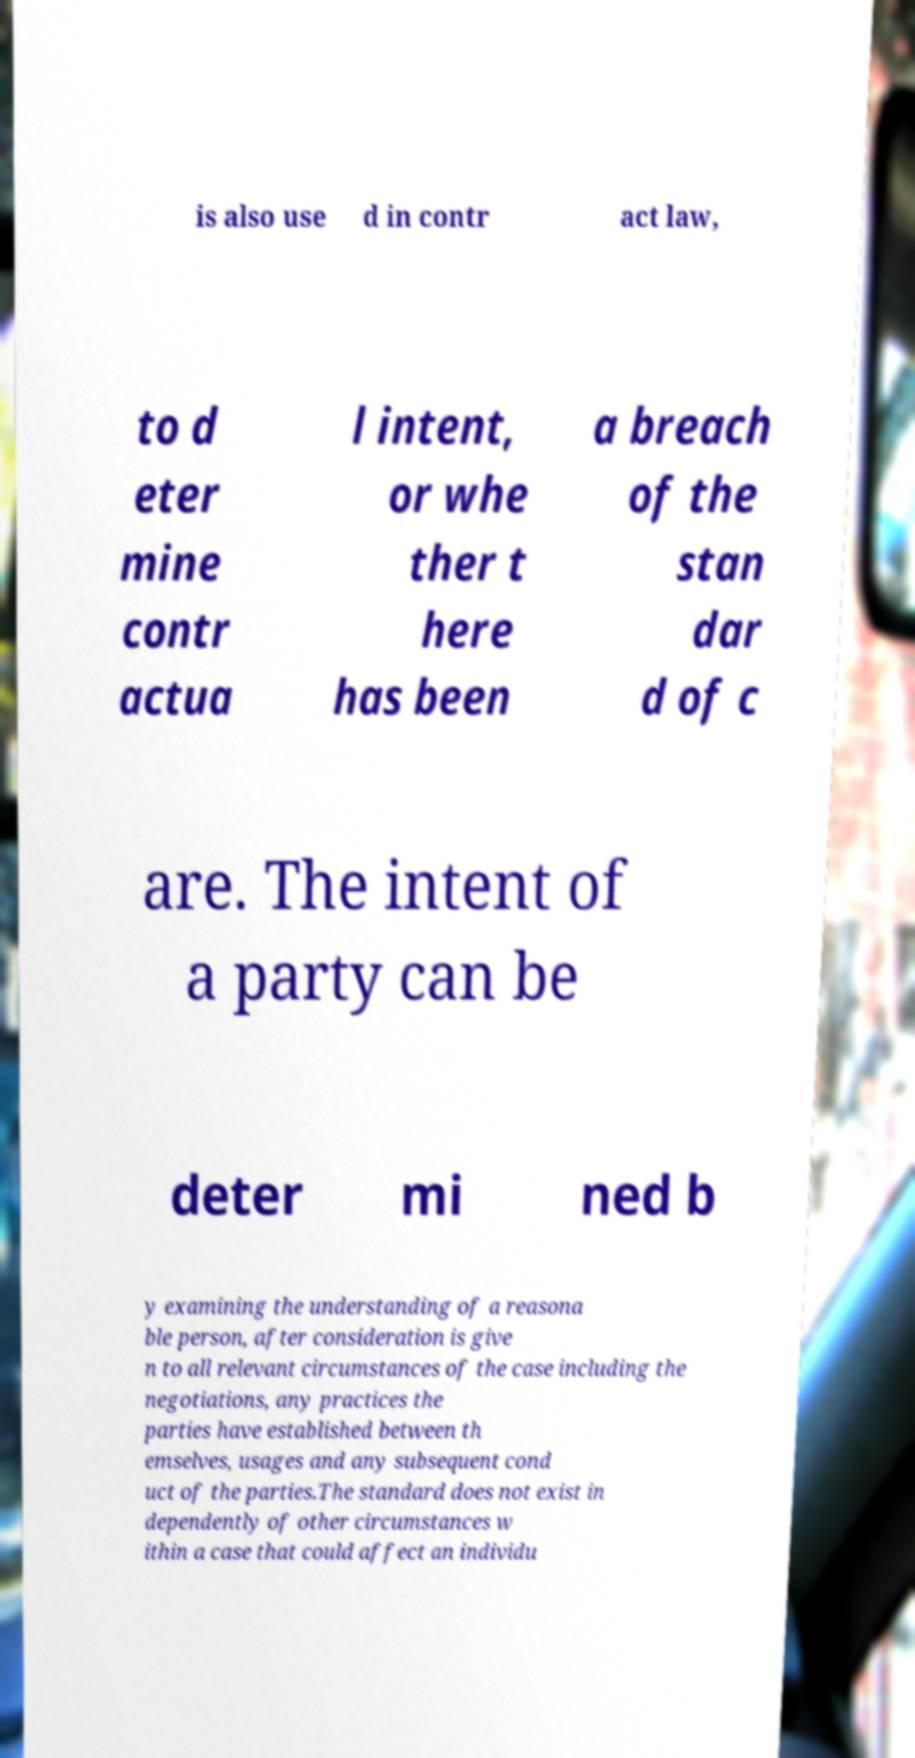There's text embedded in this image that I need extracted. Can you transcribe it verbatim? is also use d in contr act law, to d eter mine contr actua l intent, or whe ther t here has been a breach of the stan dar d of c are. The intent of a party can be deter mi ned b y examining the understanding of a reasona ble person, after consideration is give n to all relevant circumstances of the case including the negotiations, any practices the parties have established between th emselves, usages and any subsequent cond uct of the parties.The standard does not exist in dependently of other circumstances w ithin a case that could affect an individu 